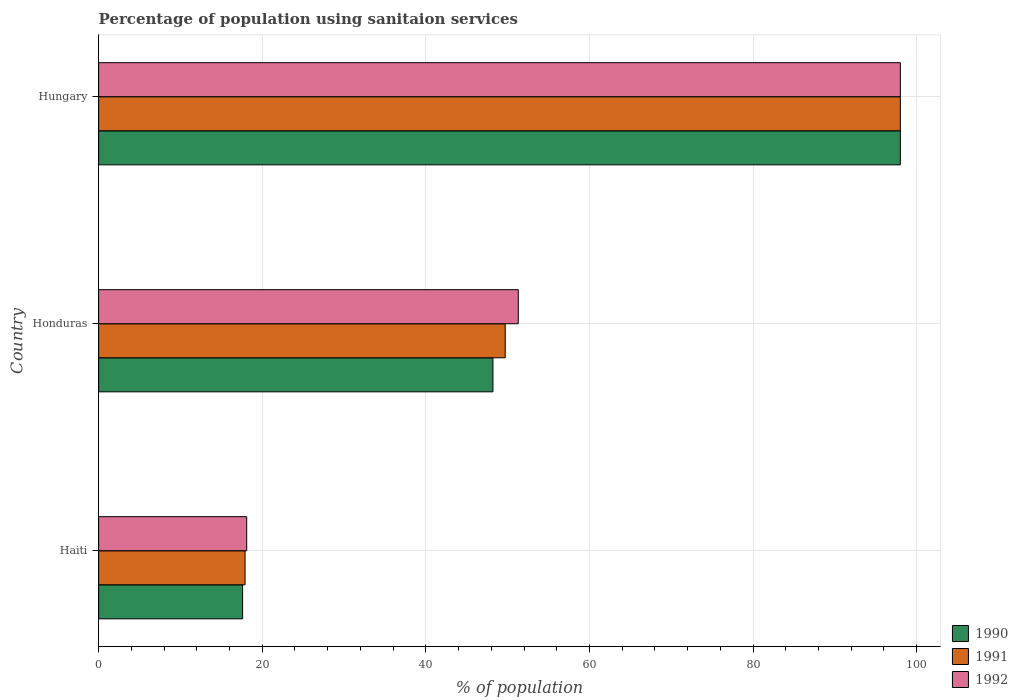Are the number of bars per tick equal to the number of legend labels?
Provide a succinct answer. Yes. How many bars are there on the 2nd tick from the bottom?
Offer a very short reply. 3. What is the label of the 2nd group of bars from the top?
Your answer should be compact. Honduras. What is the percentage of population using sanitaion services in 1990 in Honduras?
Provide a short and direct response. 48.2. In which country was the percentage of population using sanitaion services in 1992 maximum?
Your answer should be compact. Hungary. In which country was the percentage of population using sanitaion services in 1990 minimum?
Your answer should be compact. Haiti. What is the total percentage of population using sanitaion services in 1991 in the graph?
Provide a succinct answer. 165.6. What is the difference between the percentage of population using sanitaion services in 1991 in Haiti and that in Hungary?
Ensure brevity in your answer.  -80.1. What is the difference between the percentage of population using sanitaion services in 1990 in Haiti and the percentage of population using sanitaion services in 1991 in Hungary?
Make the answer very short. -80.4. What is the average percentage of population using sanitaion services in 1990 per country?
Ensure brevity in your answer.  54.6. What is the difference between the percentage of population using sanitaion services in 1992 and percentage of population using sanitaion services in 1990 in Haiti?
Offer a very short reply. 0.5. What is the ratio of the percentage of population using sanitaion services in 1990 in Haiti to that in Hungary?
Provide a succinct answer. 0.18. What is the difference between the highest and the second highest percentage of population using sanitaion services in 1991?
Offer a terse response. 48.3. What is the difference between the highest and the lowest percentage of population using sanitaion services in 1990?
Offer a terse response. 80.4. In how many countries, is the percentage of population using sanitaion services in 1992 greater than the average percentage of population using sanitaion services in 1992 taken over all countries?
Make the answer very short. 1. Is the sum of the percentage of population using sanitaion services in 1991 in Haiti and Hungary greater than the maximum percentage of population using sanitaion services in 1990 across all countries?
Provide a short and direct response. Yes. What does the 3rd bar from the top in Hungary represents?
Provide a succinct answer. 1990. Is it the case that in every country, the sum of the percentage of population using sanitaion services in 1992 and percentage of population using sanitaion services in 1991 is greater than the percentage of population using sanitaion services in 1990?
Give a very brief answer. Yes. Are the values on the major ticks of X-axis written in scientific E-notation?
Your answer should be compact. No. Does the graph contain any zero values?
Make the answer very short. No. Does the graph contain grids?
Offer a very short reply. Yes. Where does the legend appear in the graph?
Provide a succinct answer. Bottom right. How many legend labels are there?
Keep it short and to the point. 3. What is the title of the graph?
Make the answer very short. Percentage of population using sanitaion services. Does "1984" appear as one of the legend labels in the graph?
Provide a short and direct response. No. What is the label or title of the X-axis?
Provide a succinct answer. % of population. What is the label or title of the Y-axis?
Keep it short and to the point. Country. What is the % of population of 1990 in Honduras?
Make the answer very short. 48.2. What is the % of population in 1991 in Honduras?
Your answer should be compact. 49.7. What is the % of population in 1992 in Honduras?
Provide a succinct answer. 51.3. What is the % of population of 1990 in Hungary?
Offer a terse response. 98. What is the % of population of 1991 in Hungary?
Give a very brief answer. 98. Across all countries, what is the maximum % of population of 1991?
Your response must be concise. 98. Across all countries, what is the minimum % of population of 1990?
Provide a short and direct response. 17.6. Across all countries, what is the minimum % of population of 1991?
Make the answer very short. 17.9. What is the total % of population in 1990 in the graph?
Your answer should be very brief. 163.8. What is the total % of population in 1991 in the graph?
Ensure brevity in your answer.  165.6. What is the total % of population in 1992 in the graph?
Your answer should be very brief. 167.4. What is the difference between the % of population in 1990 in Haiti and that in Honduras?
Give a very brief answer. -30.6. What is the difference between the % of population in 1991 in Haiti and that in Honduras?
Keep it short and to the point. -31.8. What is the difference between the % of population in 1992 in Haiti and that in Honduras?
Keep it short and to the point. -33.2. What is the difference between the % of population in 1990 in Haiti and that in Hungary?
Offer a terse response. -80.4. What is the difference between the % of population in 1991 in Haiti and that in Hungary?
Keep it short and to the point. -80.1. What is the difference between the % of population in 1992 in Haiti and that in Hungary?
Keep it short and to the point. -79.9. What is the difference between the % of population of 1990 in Honduras and that in Hungary?
Ensure brevity in your answer.  -49.8. What is the difference between the % of population in 1991 in Honduras and that in Hungary?
Ensure brevity in your answer.  -48.3. What is the difference between the % of population in 1992 in Honduras and that in Hungary?
Your answer should be very brief. -46.7. What is the difference between the % of population in 1990 in Haiti and the % of population in 1991 in Honduras?
Your answer should be very brief. -32.1. What is the difference between the % of population in 1990 in Haiti and the % of population in 1992 in Honduras?
Your answer should be very brief. -33.7. What is the difference between the % of population of 1991 in Haiti and the % of population of 1992 in Honduras?
Make the answer very short. -33.4. What is the difference between the % of population in 1990 in Haiti and the % of population in 1991 in Hungary?
Offer a very short reply. -80.4. What is the difference between the % of population in 1990 in Haiti and the % of population in 1992 in Hungary?
Offer a terse response. -80.4. What is the difference between the % of population in 1991 in Haiti and the % of population in 1992 in Hungary?
Your answer should be compact. -80.1. What is the difference between the % of population of 1990 in Honduras and the % of population of 1991 in Hungary?
Provide a short and direct response. -49.8. What is the difference between the % of population of 1990 in Honduras and the % of population of 1992 in Hungary?
Give a very brief answer. -49.8. What is the difference between the % of population in 1991 in Honduras and the % of population in 1992 in Hungary?
Keep it short and to the point. -48.3. What is the average % of population in 1990 per country?
Provide a succinct answer. 54.6. What is the average % of population in 1991 per country?
Your response must be concise. 55.2. What is the average % of population of 1992 per country?
Provide a succinct answer. 55.8. What is the difference between the % of population in 1990 and % of population in 1991 in Honduras?
Provide a succinct answer. -1.5. What is the difference between the % of population in 1990 and % of population in 1992 in Honduras?
Your answer should be very brief. -3.1. What is the difference between the % of population of 1991 and % of population of 1992 in Honduras?
Give a very brief answer. -1.6. What is the difference between the % of population in 1991 and % of population in 1992 in Hungary?
Offer a terse response. 0. What is the ratio of the % of population in 1990 in Haiti to that in Honduras?
Your answer should be compact. 0.37. What is the ratio of the % of population of 1991 in Haiti to that in Honduras?
Make the answer very short. 0.36. What is the ratio of the % of population in 1992 in Haiti to that in Honduras?
Your response must be concise. 0.35. What is the ratio of the % of population of 1990 in Haiti to that in Hungary?
Make the answer very short. 0.18. What is the ratio of the % of population of 1991 in Haiti to that in Hungary?
Provide a short and direct response. 0.18. What is the ratio of the % of population of 1992 in Haiti to that in Hungary?
Keep it short and to the point. 0.18. What is the ratio of the % of population in 1990 in Honduras to that in Hungary?
Keep it short and to the point. 0.49. What is the ratio of the % of population of 1991 in Honduras to that in Hungary?
Provide a succinct answer. 0.51. What is the ratio of the % of population in 1992 in Honduras to that in Hungary?
Offer a very short reply. 0.52. What is the difference between the highest and the second highest % of population in 1990?
Offer a very short reply. 49.8. What is the difference between the highest and the second highest % of population of 1991?
Your answer should be very brief. 48.3. What is the difference between the highest and the second highest % of population in 1992?
Provide a short and direct response. 46.7. What is the difference between the highest and the lowest % of population in 1990?
Your answer should be very brief. 80.4. What is the difference between the highest and the lowest % of population of 1991?
Offer a terse response. 80.1. What is the difference between the highest and the lowest % of population in 1992?
Provide a short and direct response. 79.9. 